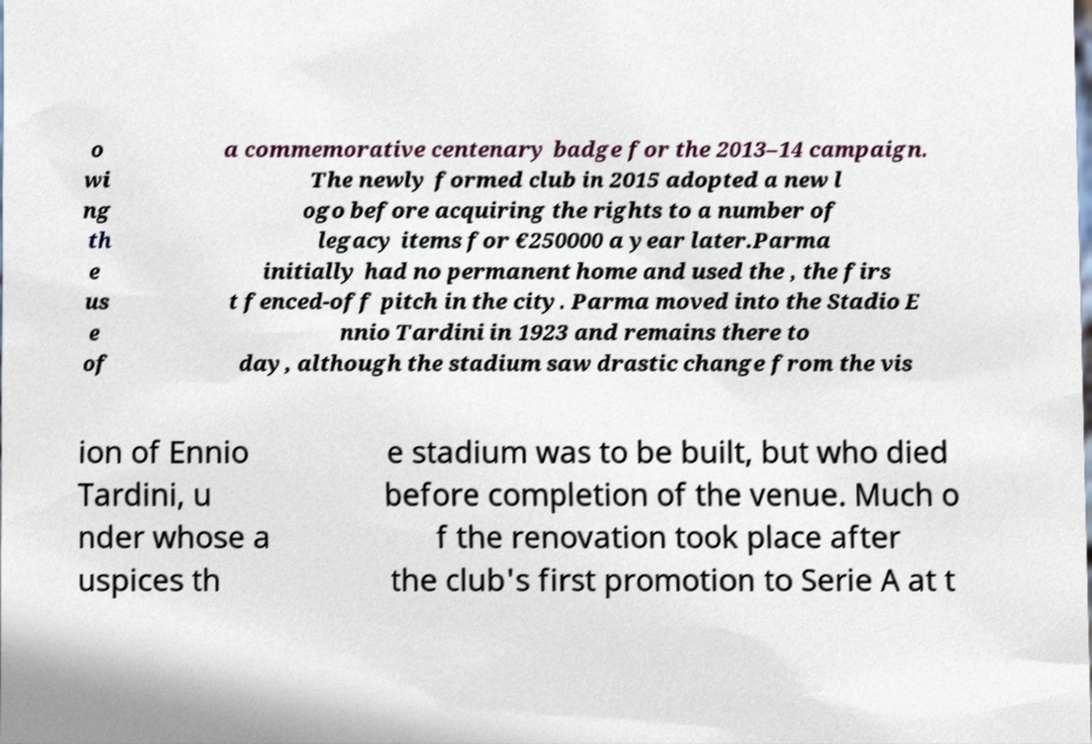For documentation purposes, I need the text within this image transcribed. Could you provide that? o wi ng th e us e of a commemorative centenary badge for the 2013–14 campaign. The newly formed club in 2015 adopted a new l ogo before acquiring the rights to a number of legacy items for €250000 a year later.Parma initially had no permanent home and used the , the firs t fenced-off pitch in the city. Parma moved into the Stadio E nnio Tardini in 1923 and remains there to day, although the stadium saw drastic change from the vis ion of Ennio Tardini, u nder whose a uspices th e stadium was to be built, but who died before completion of the venue. Much o f the renovation took place after the club's first promotion to Serie A at t 